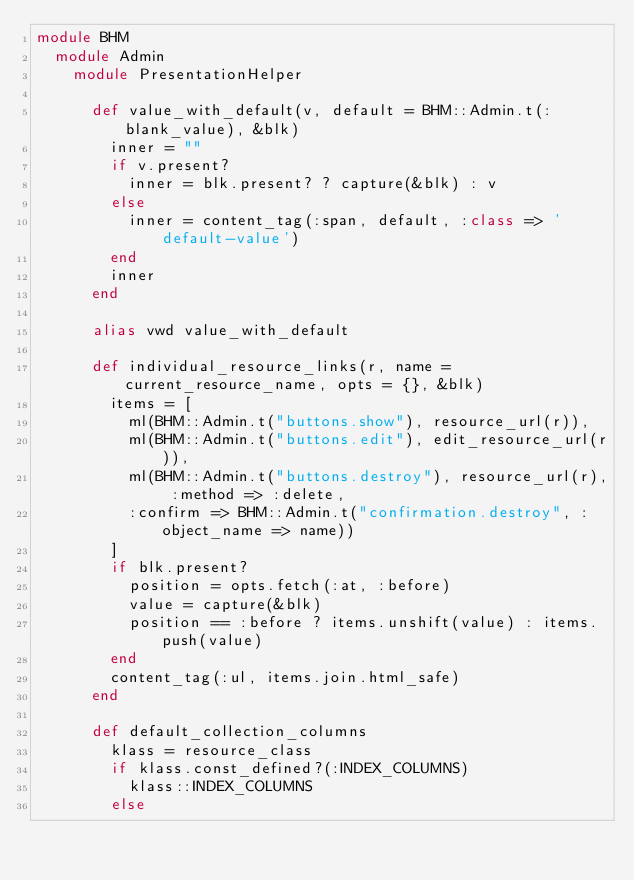Convert code to text. <code><loc_0><loc_0><loc_500><loc_500><_Ruby_>module BHM
  module Admin
    module PresentationHelper
      
      def value_with_default(v, default = BHM::Admin.t(:blank_value), &blk)
        inner = ""
        if v.present?
          inner = blk.present? ? capture(&blk) : v
        else
          inner = content_tag(:span, default, :class => 'default-value')
        end
        inner
      end

      alias vwd value_with_default
      
      def individual_resource_links(r, name = current_resource_name, opts = {}, &blk)
        items = [
          ml(BHM::Admin.t("buttons.show"), resource_url(r)),
          ml(BHM::Admin.t("buttons.edit"), edit_resource_url(r)),
          ml(BHM::Admin.t("buttons.destroy"), resource_url(r), :method => :delete,
          :confirm => BHM::Admin.t("confirmation.destroy", :object_name => name))
        ]
        if blk.present?
          position = opts.fetch(:at, :before)
          value = capture(&blk)
          position == :before ? items.unshift(value) : items.push(value)
        end
        content_tag(:ul, items.join.html_safe)
      end

      def default_collection_columns
        klass = resource_class
        if klass.const_defined?(:INDEX_COLUMNS)
          klass::INDEX_COLUMNS
        else</code> 